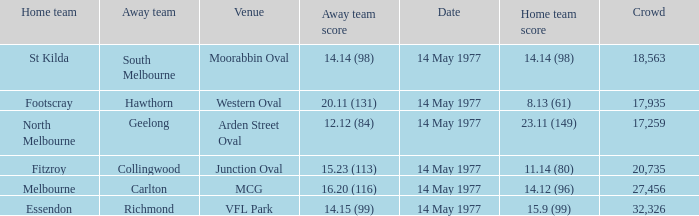Name the away team for essendon Richmond. 